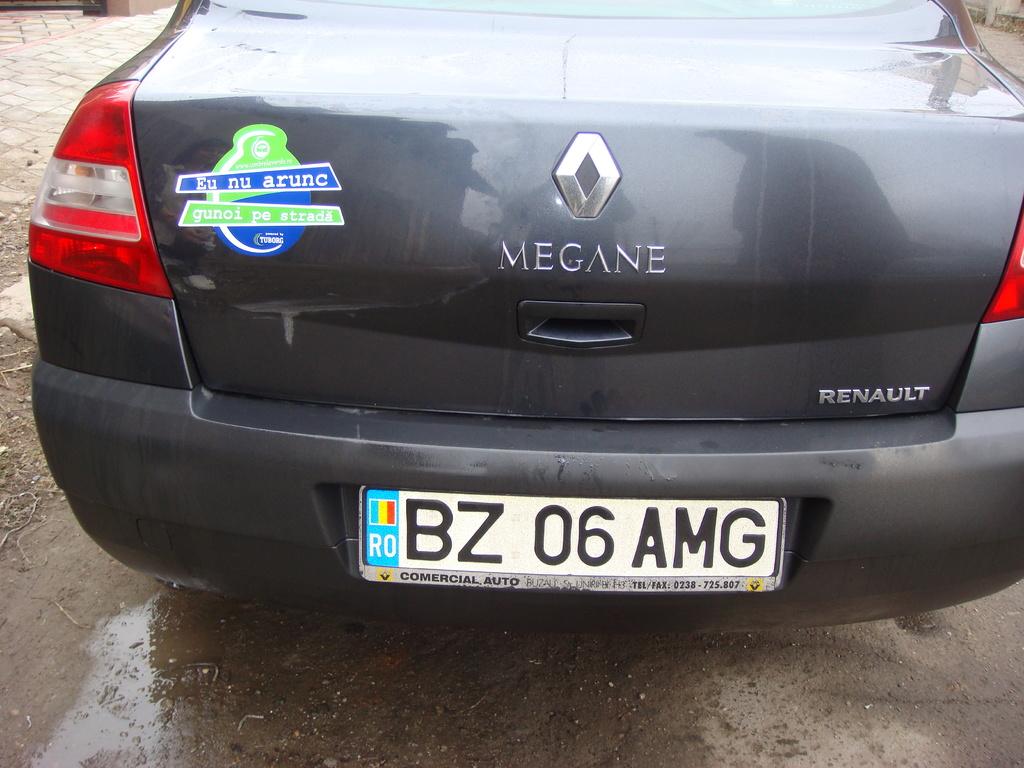What is the license plate number?
Ensure brevity in your answer.  Bz 06 amg. What brand is the car?
Offer a terse response. Renault. 